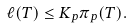Convert formula to latex. <formula><loc_0><loc_0><loc_500><loc_500>\ell ( T ) \leq K _ { p } \pi _ { p } ( T ) .</formula> 